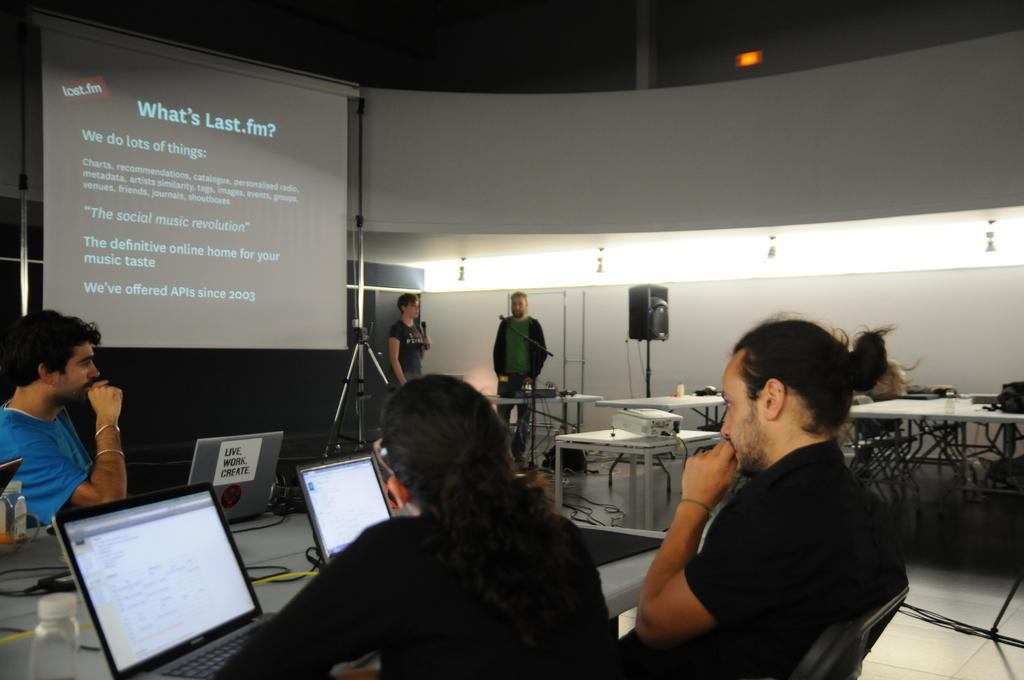<image>
Write a terse but informative summary of the picture. several people sitting in front of laptops and screen on wall showing What's Last.fm 